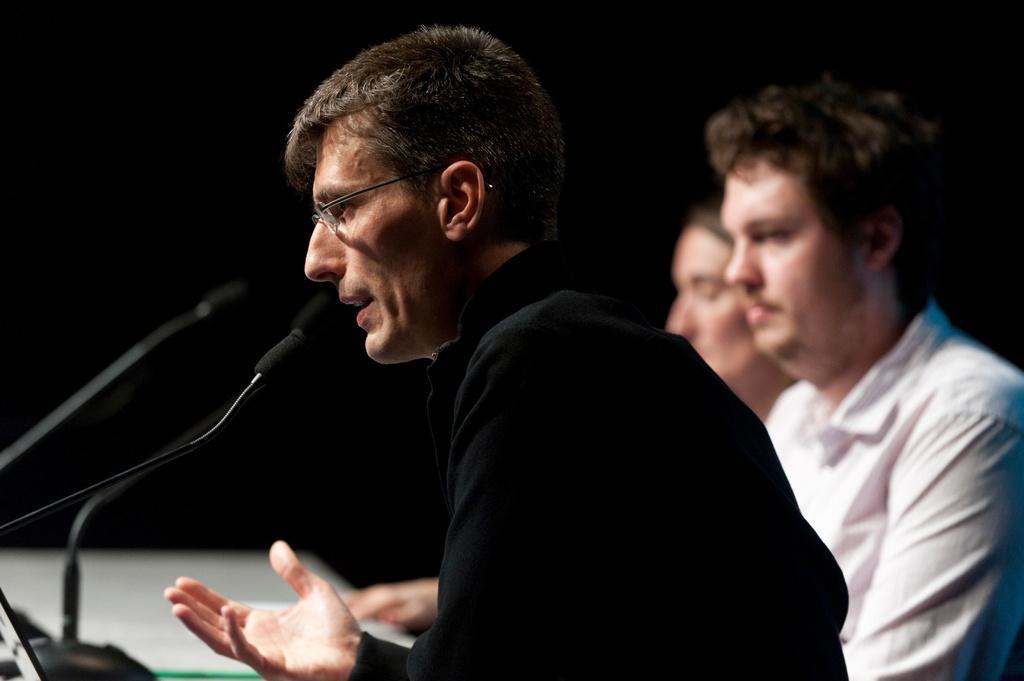In one or two sentences, can you explain what this image depicts? In this picture we can see a there are three people sitting and in front of the people there are microphones with stands. A man in the black shirt is explaining something. Behind the people there is the dark background. 